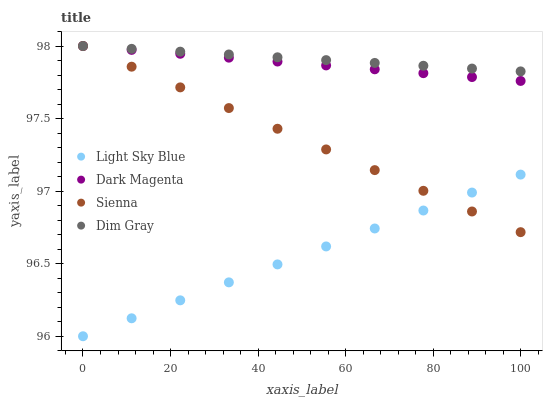Does Light Sky Blue have the minimum area under the curve?
Answer yes or no. Yes. Does Dim Gray have the maximum area under the curve?
Answer yes or no. Yes. Does Dim Gray have the minimum area under the curve?
Answer yes or no. No. Does Light Sky Blue have the maximum area under the curve?
Answer yes or no. No. Is Light Sky Blue the smoothest?
Answer yes or no. Yes. Is Dim Gray the roughest?
Answer yes or no. Yes. Is Dim Gray the smoothest?
Answer yes or no. No. Is Light Sky Blue the roughest?
Answer yes or no. No. Does Light Sky Blue have the lowest value?
Answer yes or no. Yes. Does Dim Gray have the lowest value?
Answer yes or no. No. Does Dark Magenta have the highest value?
Answer yes or no. Yes. Does Light Sky Blue have the highest value?
Answer yes or no. No. Is Light Sky Blue less than Dim Gray?
Answer yes or no. Yes. Is Dark Magenta greater than Light Sky Blue?
Answer yes or no. Yes. Does Dark Magenta intersect Dim Gray?
Answer yes or no. Yes. Is Dark Magenta less than Dim Gray?
Answer yes or no. No. Is Dark Magenta greater than Dim Gray?
Answer yes or no. No. Does Light Sky Blue intersect Dim Gray?
Answer yes or no. No. 